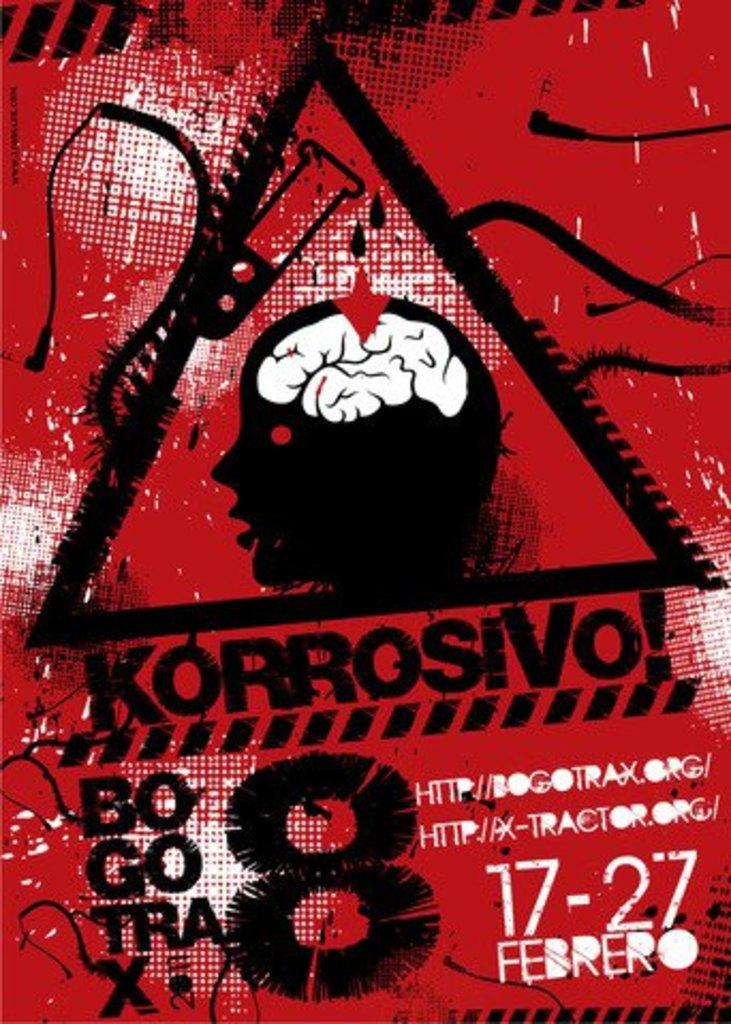What is the main subject of the image? The main subject of the image is a graphical picture of a person's brain. Can you describe any additional elements in the image? Yes, there is text visible in the background of the image. How many fairies are dancing on the ground in the image? There are no fairies or ground present in the image; it features a graphical picture of a person's brain and text in the background. 